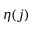<formula> <loc_0><loc_0><loc_500><loc_500>\eta ( j )</formula> 